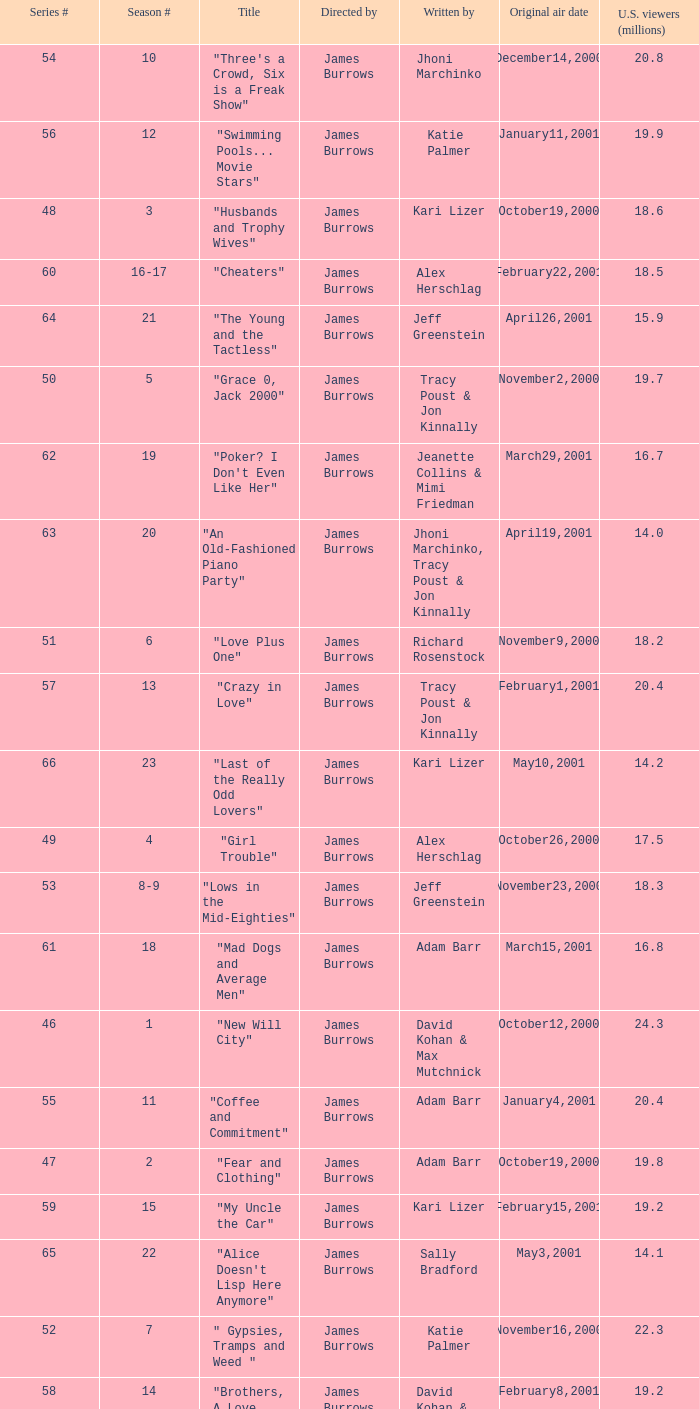Who wrote the episode titled "An Old-fashioned Piano Party"? Jhoni Marchinko, Tracy Poust & Jon Kinnally. 